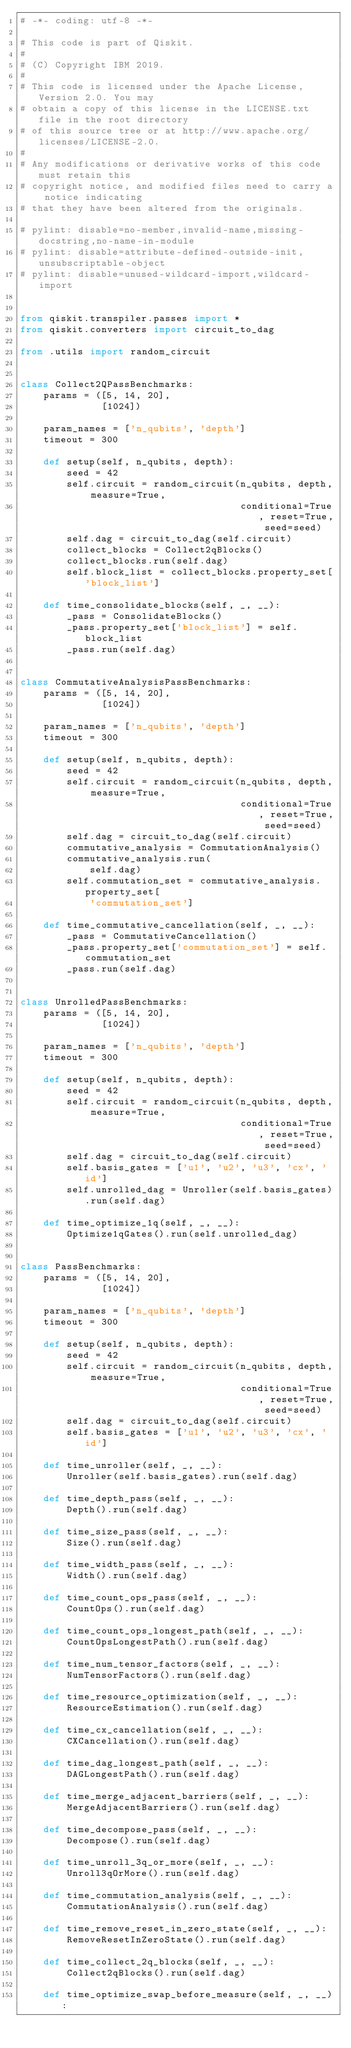<code> <loc_0><loc_0><loc_500><loc_500><_Python_># -*- coding: utf-8 -*-

# This code is part of Qiskit.
#
# (C) Copyright IBM 2019.
#
# This code is licensed under the Apache License, Version 2.0. You may
# obtain a copy of this license in the LICENSE.txt file in the root directory
# of this source tree or at http://www.apache.org/licenses/LICENSE-2.0.
#
# Any modifications or derivative works of this code must retain this
# copyright notice, and modified files need to carry a notice indicating
# that they have been altered from the originals.

# pylint: disable=no-member,invalid-name,missing-docstring,no-name-in-module
# pylint: disable=attribute-defined-outside-init,unsubscriptable-object
# pylint: disable=unused-wildcard-import,wildcard-import


from qiskit.transpiler.passes import *
from qiskit.converters import circuit_to_dag

from .utils import random_circuit


class Collect2QPassBenchmarks:
    params = ([5, 14, 20],
              [1024])

    param_names = ['n_qubits', 'depth']
    timeout = 300

    def setup(self, n_qubits, depth):
        seed = 42
        self.circuit = random_circuit(n_qubits, depth, measure=True,
                                      conditional=True, reset=True, seed=seed)
        self.dag = circuit_to_dag(self.circuit)
        collect_blocks = Collect2qBlocks()
        collect_blocks.run(self.dag)
        self.block_list = collect_blocks.property_set['block_list']

    def time_consolidate_blocks(self, _, __):
        _pass = ConsolidateBlocks()
        _pass.property_set['block_list'] = self.block_list
        _pass.run(self.dag)


class CommutativeAnalysisPassBenchmarks:
    params = ([5, 14, 20],
              [1024])

    param_names = ['n_qubits', 'depth']
    timeout = 300

    def setup(self, n_qubits, depth):
        seed = 42
        self.circuit = random_circuit(n_qubits, depth, measure=True,
                                      conditional=True, reset=True, seed=seed)
        self.dag = circuit_to_dag(self.circuit)
        commutative_analysis = CommutationAnalysis()
        commutative_analysis.run(
            self.dag)
        self.commutation_set = commutative_analysis.property_set[
            'commutation_set']

    def time_commutative_cancellation(self, _, __):
        _pass = CommutativeCancellation()
        _pass.property_set['commutation_set'] = self.commutation_set
        _pass.run(self.dag)


class UnrolledPassBenchmarks:
    params = ([5, 14, 20],
              [1024])

    param_names = ['n_qubits', 'depth']
    timeout = 300

    def setup(self, n_qubits, depth):
        seed = 42
        self.circuit = random_circuit(n_qubits, depth, measure=True,
                                      conditional=True, reset=True, seed=seed)
        self.dag = circuit_to_dag(self.circuit)
        self.basis_gates = ['u1', 'u2', 'u3', 'cx', 'id']
        self.unrolled_dag = Unroller(self.basis_gates).run(self.dag)

    def time_optimize_1q(self, _, __):
        Optimize1qGates().run(self.unrolled_dag)


class PassBenchmarks:
    params = ([5, 14, 20],
              [1024])

    param_names = ['n_qubits', 'depth']
    timeout = 300

    def setup(self, n_qubits, depth):
        seed = 42
        self.circuit = random_circuit(n_qubits, depth, measure=True,
                                      conditional=True, reset=True, seed=seed)
        self.dag = circuit_to_dag(self.circuit)
        self.basis_gates = ['u1', 'u2', 'u3', 'cx', 'id']

    def time_unroller(self, _, __):
        Unroller(self.basis_gates).run(self.dag)

    def time_depth_pass(self, _, __):
        Depth().run(self.dag)

    def time_size_pass(self, _, __):
        Size().run(self.dag)

    def time_width_pass(self, _, __):
        Width().run(self.dag)

    def time_count_ops_pass(self, _, __):
        CountOps().run(self.dag)

    def time_count_ops_longest_path(self, _, __):
        CountOpsLongestPath().run(self.dag)

    def time_num_tensor_factors(self, _, __):
        NumTensorFactors().run(self.dag)

    def time_resource_optimization(self, _, __):
        ResourceEstimation().run(self.dag)

    def time_cx_cancellation(self, _, __):
        CXCancellation().run(self.dag)

    def time_dag_longest_path(self, _, __):
        DAGLongestPath().run(self.dag)

    def time_merge_adjacent_barriers(self, _, __):
        MergeAdjacentBarriers().run(self.dag)

    def time_decompose_pass(self, _, __):
        Decompose().run(self.dag)

    def time_unroll_3q_or_more(self, _, __):
        Unroll3qOrMore().run(self.dag)

    def time_commutation_analysis(self, _, __):
        CommutationAnalysis().run(self.dag)

    def time_remove_reset_in_zero_state(self, _, __):
        RemoveResetInZeroState().run(self.dag)

    def time_collect_2q_blocks(self, _, __):
        Collect2qBlocks().run(self.dag)

    def time_optimize_swap_before_measure(self, _, __):</code> 